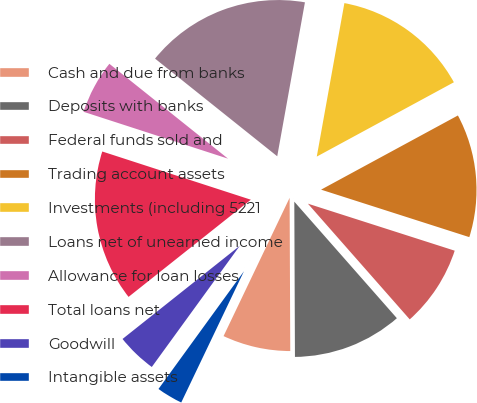Convert chart. <chart><loc_0><loc_0><loc_500><loc_500><pie_chart><fcel>Cash and due from banks<fcel>Deposits with banks<fcel>Federal funds sold and<fcel>Trading account assets<fcel>Investments (including 5221<fcel>Loans net of unearned income<fcel>Allowance for loan losses<fcel>Total loans net<fcel>Goodwill<fcel>Intangible assets<nl><fcel>7.16%<fcel>11.42%<fcel>8.58%<fcel>12.84%<fcel>14.26%<fcel>17.1%<fcel>5.74%<fcel>15.68%<fcel>4.32%<fcel>2.9%<nl></chart> 